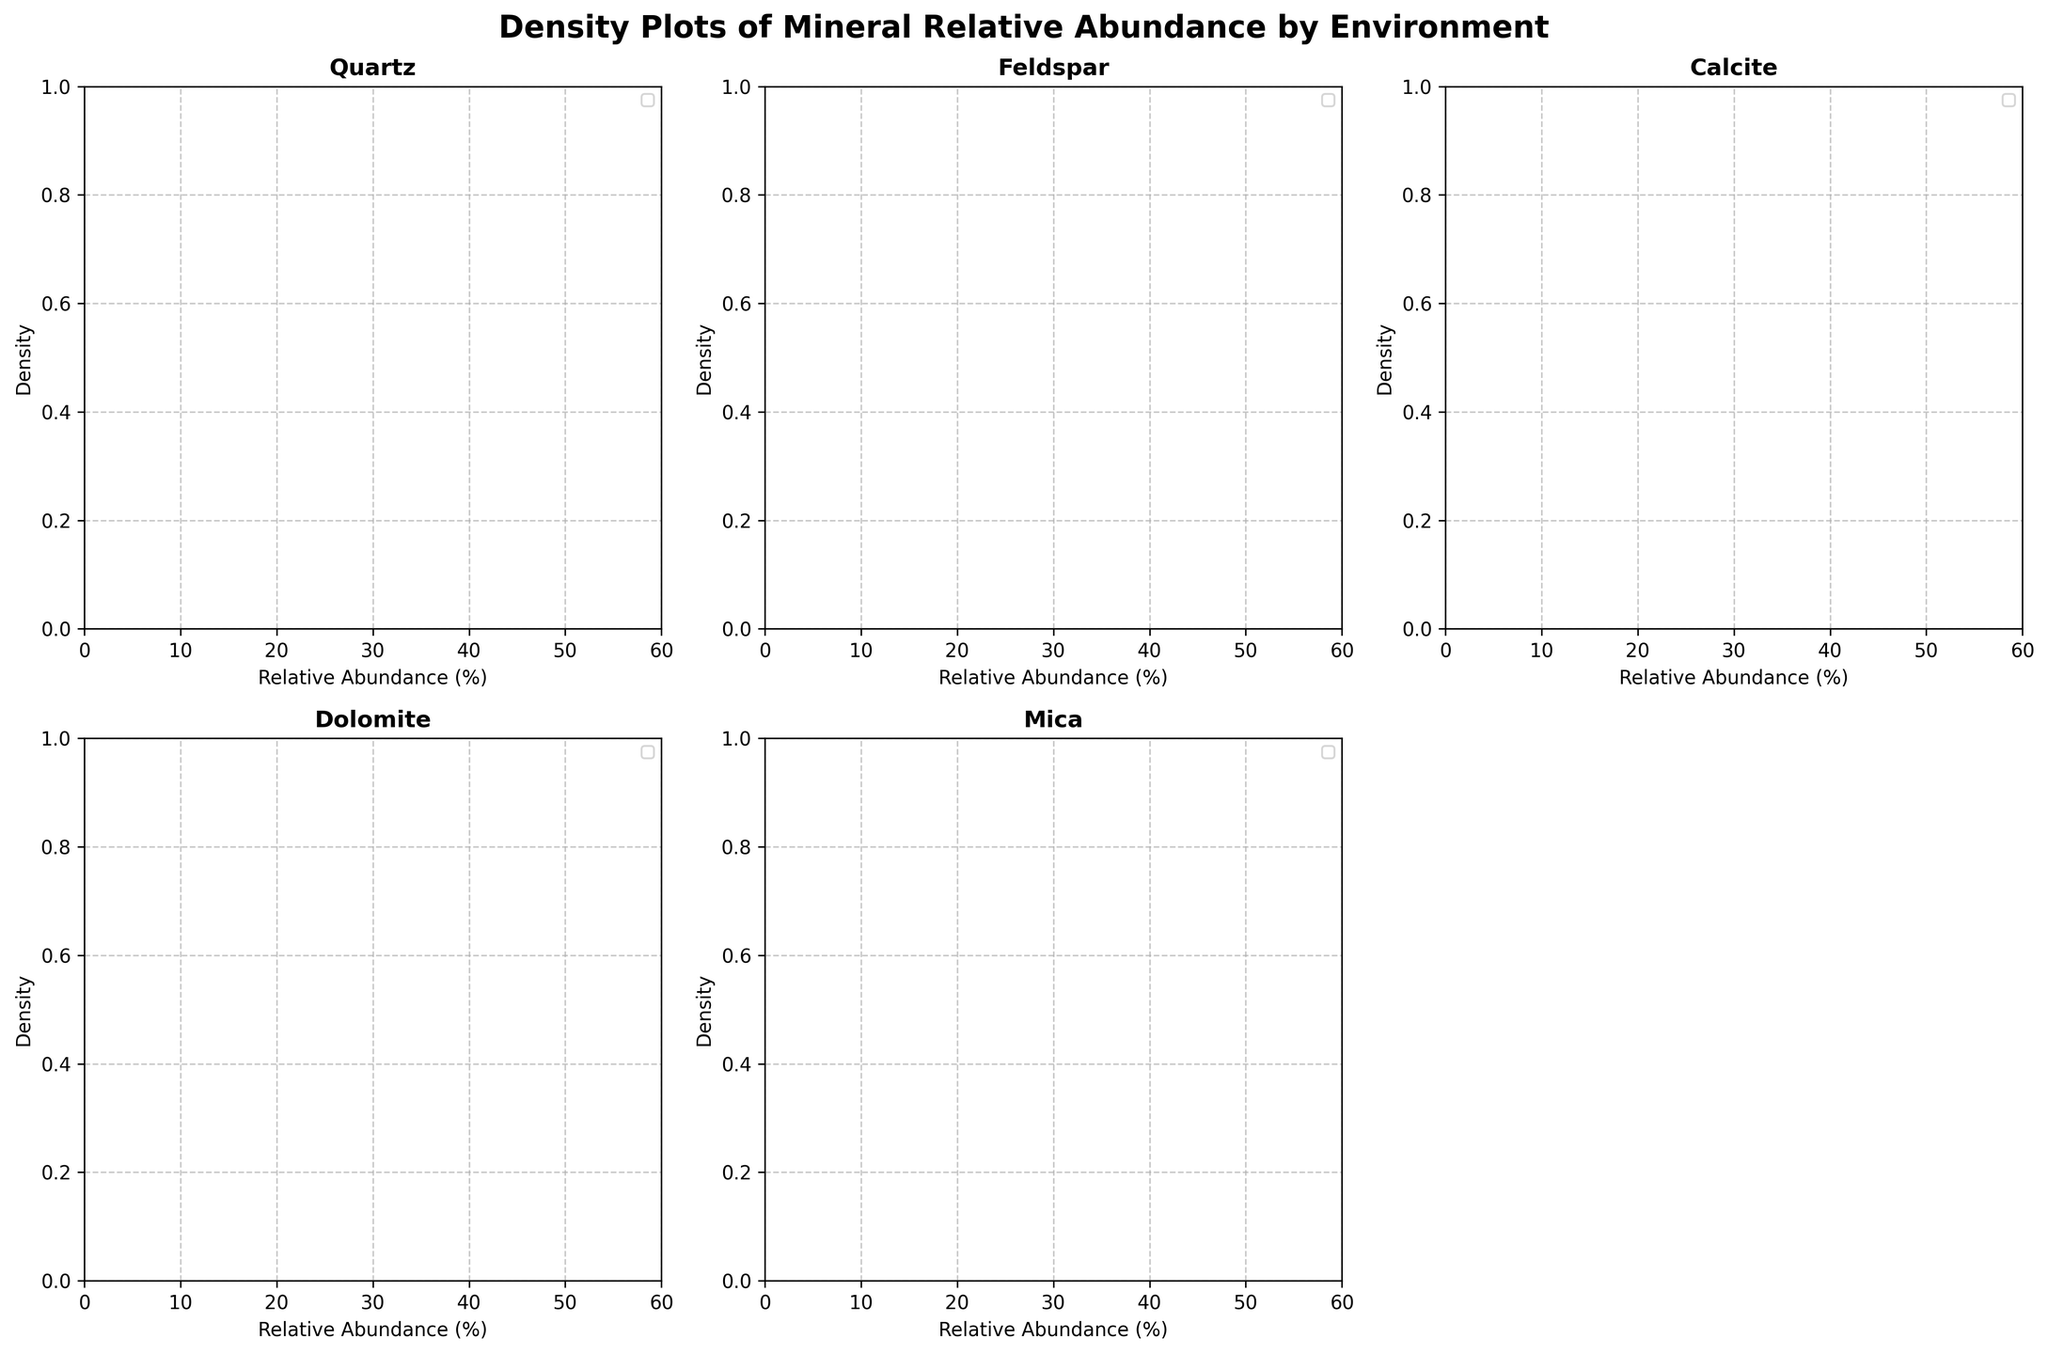What is the title of the figure? The title is located at the top of the figure and provides an overview of what the figure represents. It reads "Density Plots of Mineral Relative Abundance by Environment".
Answer: Density Plots of Mineral Relative Abundance by Environment Which environment has the highest peak for Calcite? Look at the subplot titled "Calcite" and observe the density peaks for each environment. The Lagoonal environment has the highest peak for Calcite.
Answer: Lagoonal What is the general trend in relative abundance distribution of Quartz in the Desert environment? Examine the Desert environment distribution of Quartz in the Quartz subplot. The distribution shows a unimodal peak around the higher end of the relative abundance scale, indicating a high relative abundance in the Desert environment for Quartz.
Answer: High relative abundance Is the peak density of Mica higher in Fluvial or Lagoonal environments? Compare the density peaks in the Mica subplot for Fluvial and Lagoonal environments. The Fluvial environment has a higher peak density for Mica.
Answer: Fluvial What is the common range of relative abundance for Feldspar in Marine and Lagoonal environments? On the Feldspar subplot, observe the range where the density is shaded for both Marine and Lagoonal environments. Both environments show relative abundances mostly between 5% and 15%.
Answer: 5% to 15% Which mineral shows a relative abundance peak around 40% in the Marine environment? Look through each subplot and find the one where Marine environment shows a peak at around 40%. Calcite has a peak near 40% in the Marine environment.
Answer: Calcite How does the density plot for Dolomite in Fluvial environments compare to that in Lagoonal environments? Compare the density plots of Fluvial and Lagoonal for Dolomite. The Fluvial environment shows a lower and wider density curve, while the Lagoonal environment shows a higher and sharper peak.
Answer: Fluvial - lower and wider; Lagoonal - higher and sharper Across which environment does Clay have the broadest relative abundance spread? Observe the width of the density curves in the Clay subplot. The Marine environment has the broadest spread, indicating a wide range of relative abundances for Clay in this environment.
Answer: Marine In which subplot does the Fluvial environment show the highest peak density? Visually scan through all subplots and identify the one where the Fluvial environment has the highest peak density. The Quartz subplot shows the highest peak for Fluvial.
Answer: Quartz 